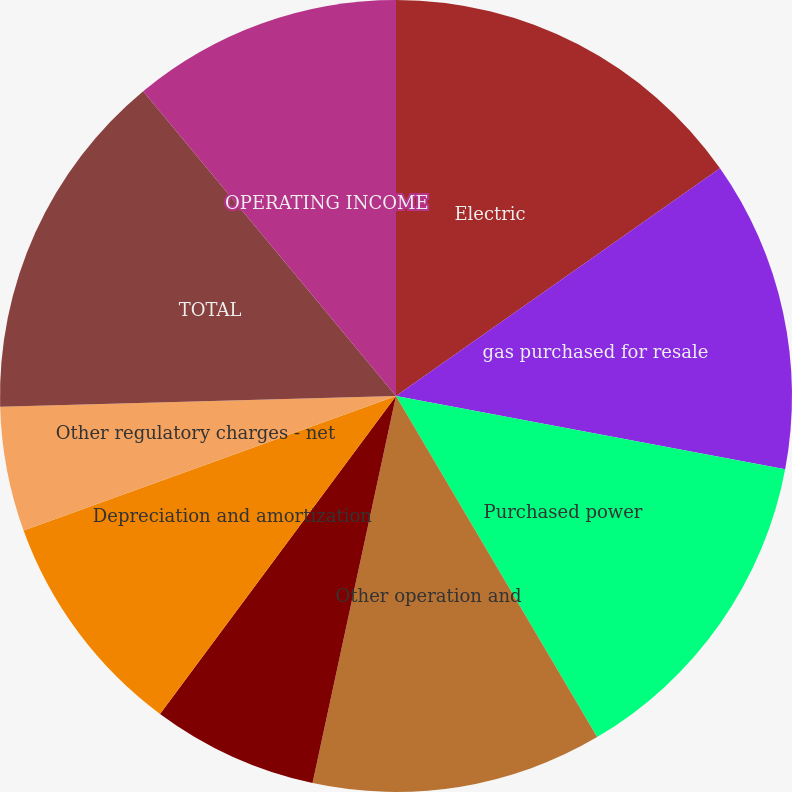Convert chart to OTSL. <chart><loc_0><loc_0><loc_500><loc_500><pie_chart><fcel>Electric<fcel>gas purchased for resale<fcel>Purchased power<fcel>Other operation and<fcel>Decommissioning<fcel>Taxes other than income taxes<fcel>Depreciation and amortization<fcel>Other regulatory charges - net<fcel>TOTAL<fcel>OPERATING INCOME<nl><fcel>15.25%<fcel>12.71%<fcel>13.56%<fcel>11.86%<fcel>0.0%<fcel>6.78%<fcel>9.32%<fcel>5.09%<fcel>14.41%<fcel>11.02%<nl></chart> 